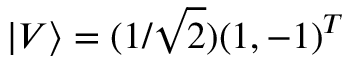Convert formula to latex. <formula><loc_0><loc_0><loc_500><loc_500>| V \rangle = ( 1 / \sqrt { 2 } ) ( 1 , - 1 ) ^ { T }</formula> 